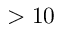Convert formula to latex. <formula><loc_0><loc_0><loc_500><loc_500>> 1 0</formula> 